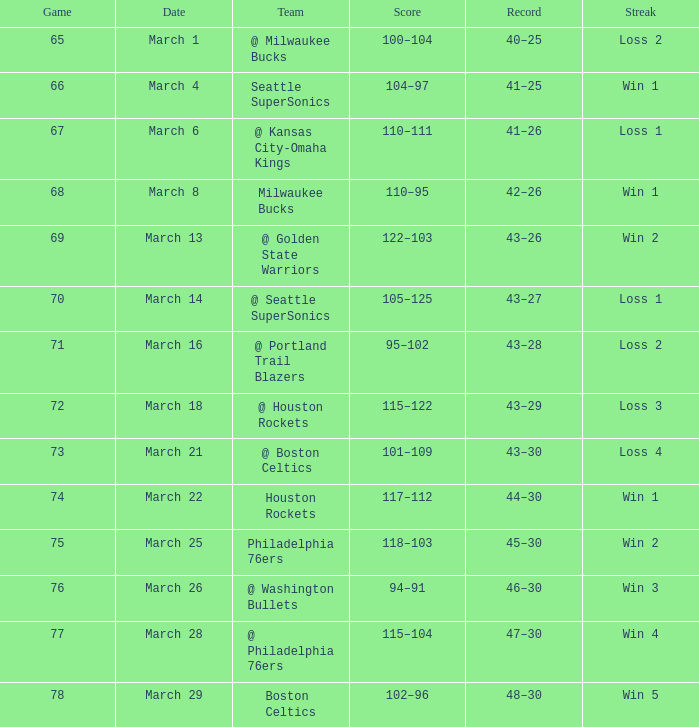What is Team, when Game is 77? @ Philadelphia 76ers. 